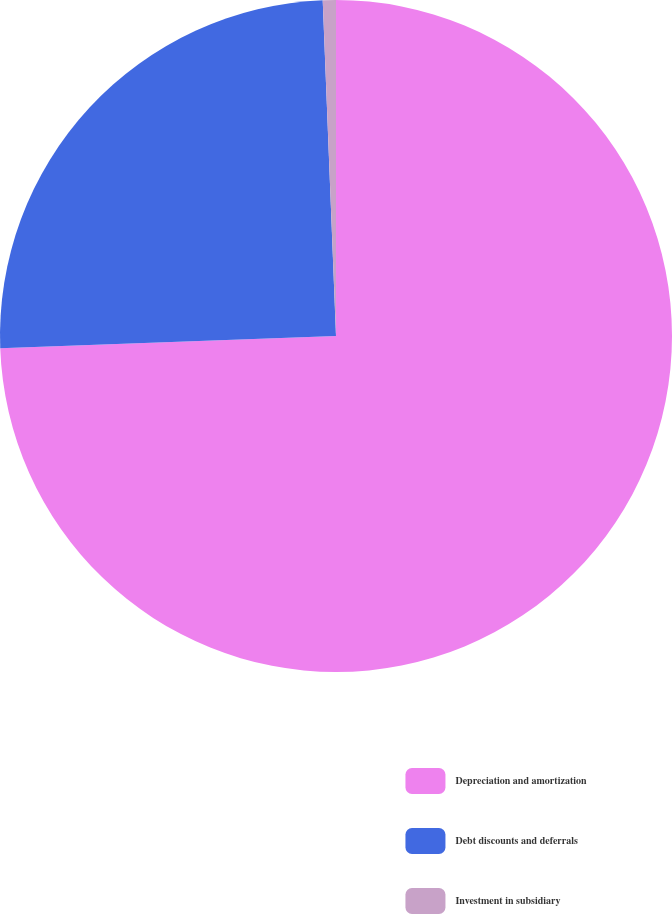Convert chart to OTSL. <chart><loc_0><loc_0><loc_500><loc_500><pie_chart><fcel>Depreciation and amortization<fcel>Debt discounts and deferrals<fcel>Investment in subsidiary<nl><fcel>74.43%<fcel>24.95%<fcel>0.63%<nl></chart> 